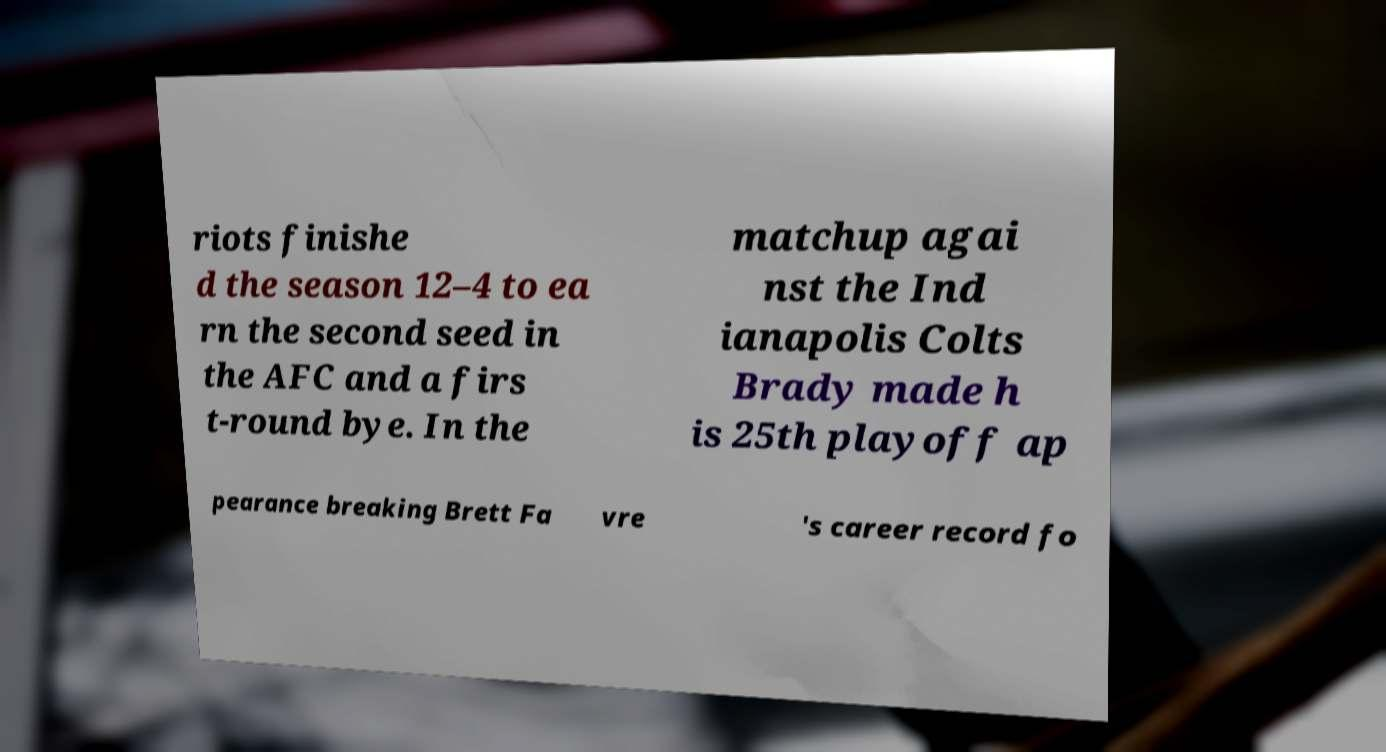Could you assist in decoding the text presented in this image and type it out clearly? riots finishe d the season 12–4 to ea rn the second seed in the AFC and a firs t-round bye. In the matchup agai nst the Ind ianapolis Colts Brady made h is 25th playoff ap pearance breaking Brett Fa vre 's career record fo 